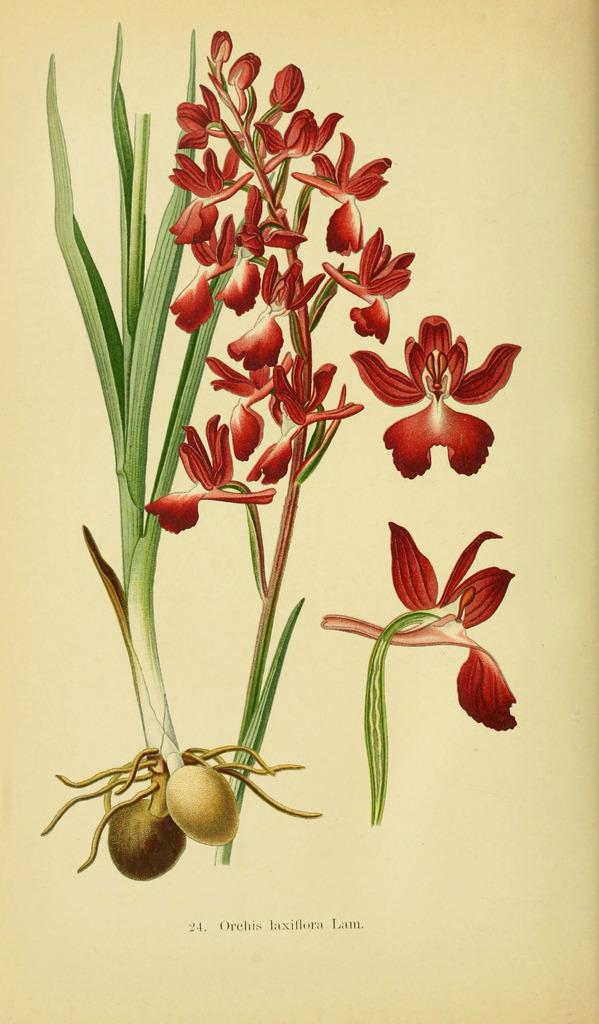What type of artwork is depicted in the image? The image is a painting. What natural elements can be seen in the painting? There are flowers and a plant in the painting. Is there any text included in the painting? Yes, there is text at the bottom of the painting. How many women are sitting on the grass in the painting? There are no women or grass present in the painting; it features flowers, a plant, and text. 